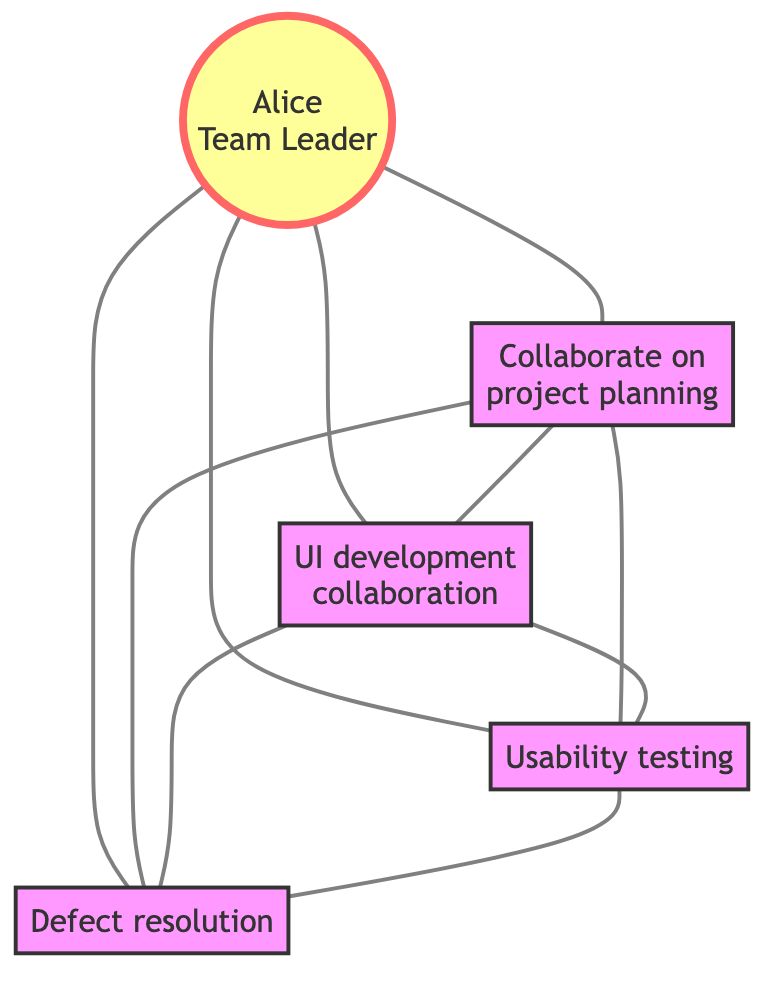What is the total number of team members? There are five nodes in the graph representing team members: Alice, Bob, Carol, David, and Eve. Counting these nodes gives us a total of five team members.
Answer: 5 Which team member is the Team Leader? In the diagram, Alice is identified as the Team Leader, which is indicated next to her name in the node.
Answer: Alice How many interactions does Bob have with other team members? Bob has connections with three other team members: Alice, Carol, and David. Count each edge connected to Bob to find a total of three interactions.
Answer: 3 What kind of interaction does Alice have with David? The edge between Alice and David shows the interaction "Quality review meetings." By looking directly at the edge label, we can find the type of interaction.
Answer: Quality review meetings Who is collaborating with Eve on the API integration? The edge connected to Eve indicates that Bob is the one collaborating with her on the API integration. By directly checking the edge label leading to Eve, we can identify Bob as the collaborator.
Answer: Bob Which two team members are connected through usability testing? The interaction label between Carol and David indicates "Usability testing." Reviewing the edges leading from each of these nodes confirms this connection.
Answer: Carol and David How many unique types of interactions are represented in the graph? If we analyze the edges, we find that there are distinct interactions such as: "Collaborate on project planning," "Brainstorming sessions," and others. Counting these unique interactions reveals a total of six types.
Answer: 6 What is the degree of the node representing Eve? Eve has connections to three other nodes: Alice, Bob, and David. The degree of a node is determined by counting the number of edges connected to it, leading us to find that Eve has three connections.
Answer: 3 Identify the team member with the most connections. By examining the edges connected to each team member, we find that Bob has the most connections with a total of four links to other members. This makes Bob the most connected member.
Answer: Bob 